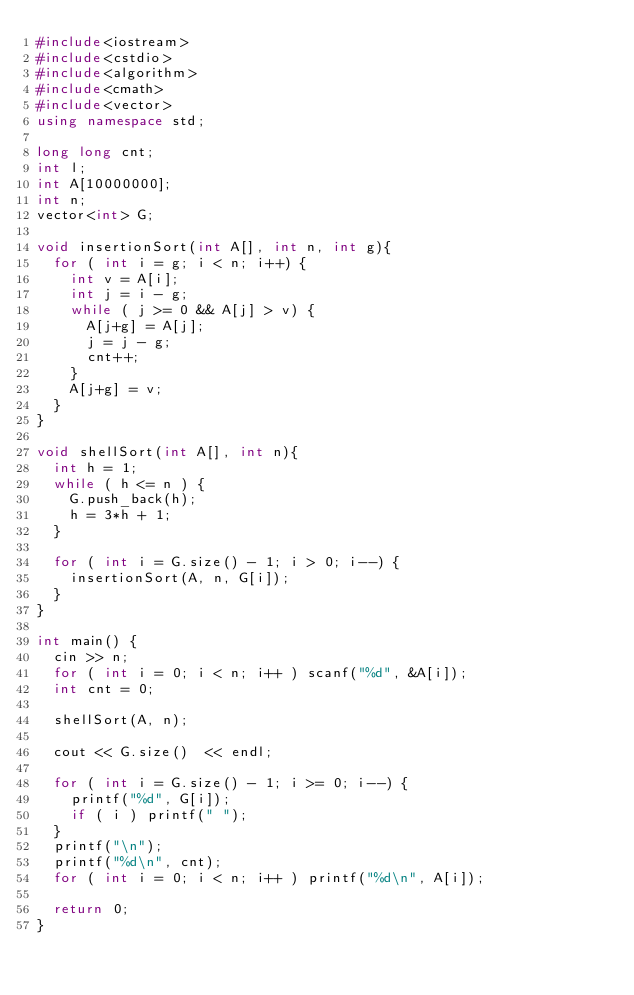<code> <loc_0><loc_0><loc_500><loc_500><_C++_>#include<iostream>
#include<cstdio>
#include<algorithm>
#include<cmath>
#include<vector>
using namespace std;

long long cnt;
int l;
int A[10000000];
int n;
vector<int> G;

void insertionSort(int A[], int n, int g){
  for ( int i = g; i < n; i++) {
    int v = A[i];
    int j = i - g;
    while ( j >= 0 && A[j] > v) {
      A[j+g] = A[j];
      j = j - g;
      cnt++;
    }
    A[j+g] = v;
  }
}

void shellSort(int A[], int n){
  int h = 1;
  while ( h <= n ) {
    G.push_back(h);
    h = 3*h + 1;
  }

  for ( int i = G.size() - 1; i > 0; i--) {
    insertionSort(A, n, G[i]);
  }
}

int main() {
  cin >> n;
  for ( int i = 0; i < n; i++ ) scanf("%d", &A[i]);
  int cnt = 0;

  shellSort(A, n);
  
  cout << G.size()  << endl;

  for ( int i = G.size() - 1; i >= 0; i--) {
    printf("%d", G[i]);
    if ( i ) printf(" ");
  }
  printf("\n");
  printf("%d\n", cnt);
  for ( int i = 0; i < n; i++ ) printf("%d\n", A[i]);

  return 0;
}
</code> 